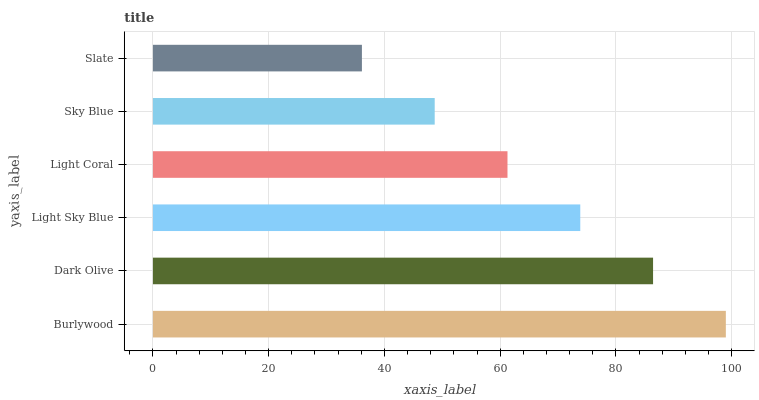Is Slate the minimum?
Answer yes or no. Yes. Is Burlywood the maximum?
Answer yes or no. Yes. Is Dark Olive the minimum?
Answer yes or no. No. Is Dark Olive the maximum?
Answer yes or no. No. Is Burlywood greater than Dark Olive?
Answer yes or no. Yes. Is Dark Olive less than Burlywood?
Answer yes or no. Yes. Is Dark Olive greater than Burlywood?
Answer yes or no. No. Is Burlywood less than Dark Olive?
Answer yes or no. No. Is Light Sky Blue the high median?
Answer yes or no. Yes. Is Light Coral the low median?
Answer yes or no. Yes. Is Light Coral the high median?
Answer yes or no. No. Is Light Sky Blue the low median?
Answer yes or no. No. 